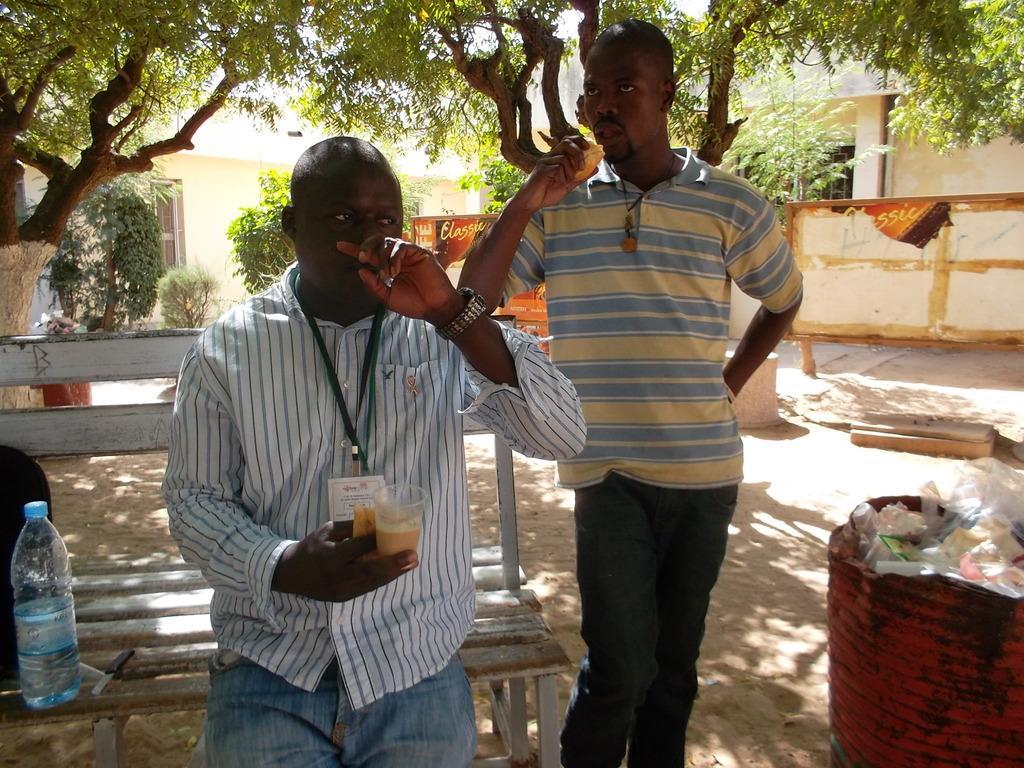Describe this image in one or two sentences. In this image there are two persons. In front the man is holding a glass. On the bench there is a water bottle and knife. At the background there is a building and a trees. 